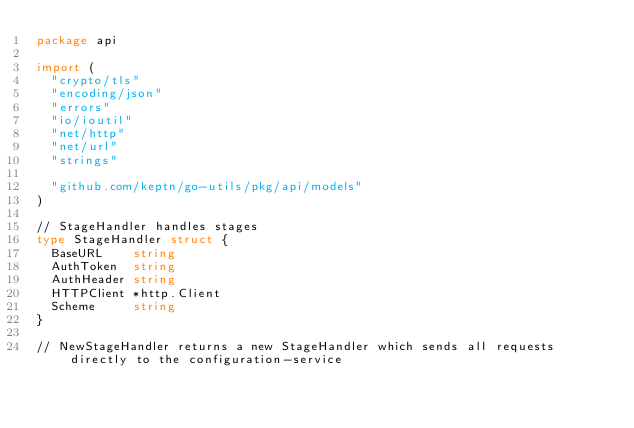<code> <loc_0><loc_0><loc_500><loc_500><_Go_>package api

import (
	"crypto/tls"
	"encoding/json"
	"errors"
	"io/ioutil"
	"net/http"
	"net/url"
	"strings"

	"github.com/keptn/go-utils/pkg/api/models"
)

// StageHandler handles stages
type StageHandler struct {
	BaseURL    string
	AuthToken  string
	AuthHeader string
	HTTPClient *http.Client
	Scheme     string
}

// NewStageHandler returns a new StageHandler which sends all requests directly to the configuration-service</code> 